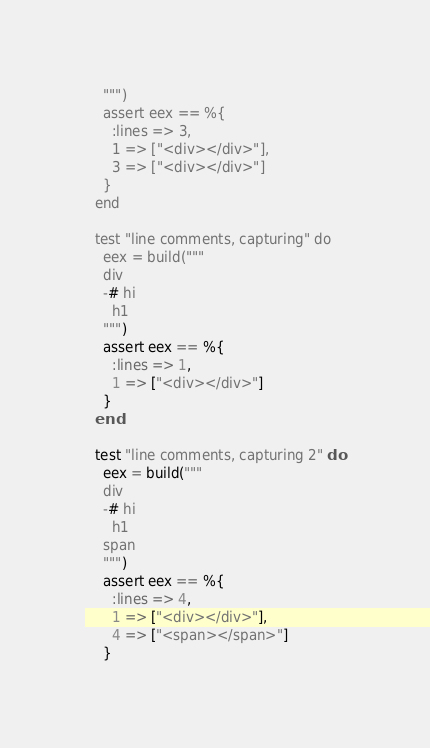Convert code to text. <code><loc_0><loc_0><loc_500><loc_500><_Elixir_>    """)
    assert eex == %{
      :lines => 3,
      1 => ["<div></div>"],
      3 => ["<div></div>"]
    }
  end

  test "line comments, capturing" do
    eex = build("""
    div
    -# hi
      h1
    """)
    assert eex == %{
      :lines => 1,
      1 => ["<div></div>"]
    }
  end

  test "line comments, capturing 2" do
    eex = build("""
    div
    -# hi
      h1
    span
    """)
    assert eex == %{
      :lines => 4,
      1 => ["<div></div>"],
      4 => ["<span></span>"]
    }</code> 